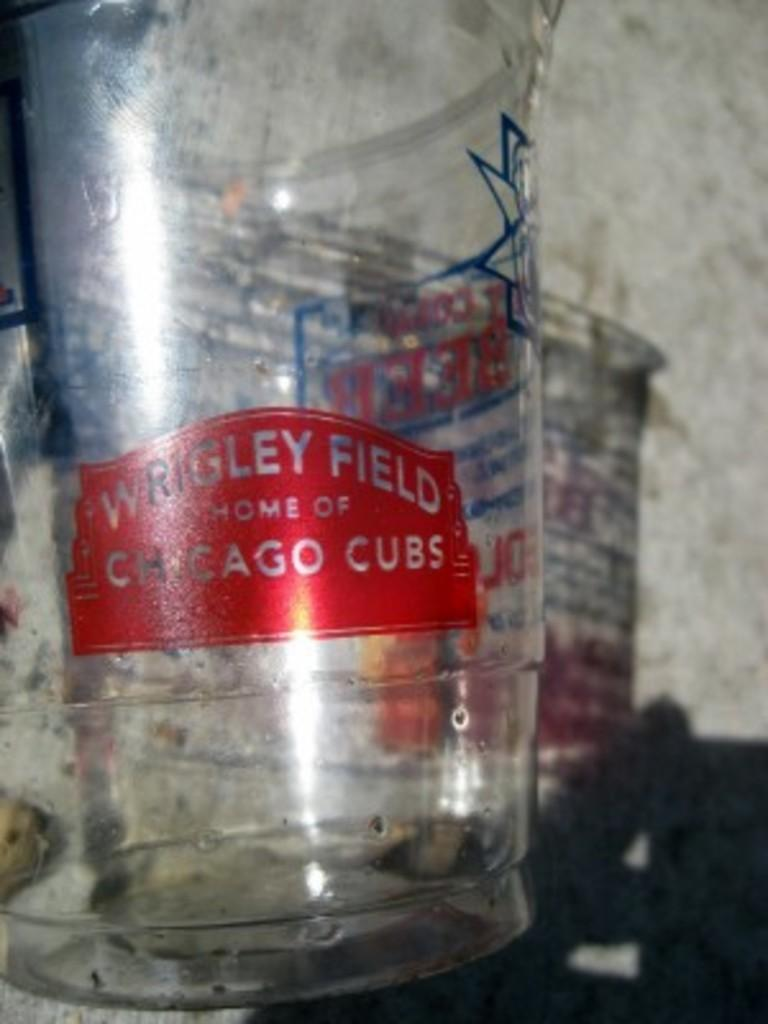<image>
Share a concise interpretation of the image provided. The clear plastic, disposable cup commemorated Wrigley Field, Home of Chicago Cubs. 